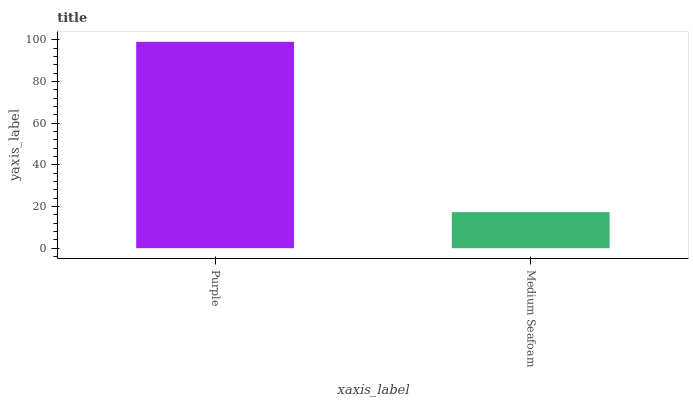Is Medium Seafoam the minimum?
Answer yes or no. Yes. Is Purple the maximum?
Answer yes or no. Yes. Is Medium Seafoam the maximum?
Answer yes or no. No. Is Purple greater than Medium Seafoam?
Answer yes or no. Yes. Is Medium Seafoam less than Purple?
Answer yes or no. Yes. Is Medium Seafoam greater than Purple?
Answer yes or no. No. Is Purple less than Medium Seafoam?
Answer yes or no. No. Is Purple the high median?
Answer yes or no. Yes. Is Medium Seafoam the low median?
Answer yes or no. Yes. Is Medium Seafoam the high median?
Answer yes or no. No. Is Purple the low median?
Answer yes or no. No. 